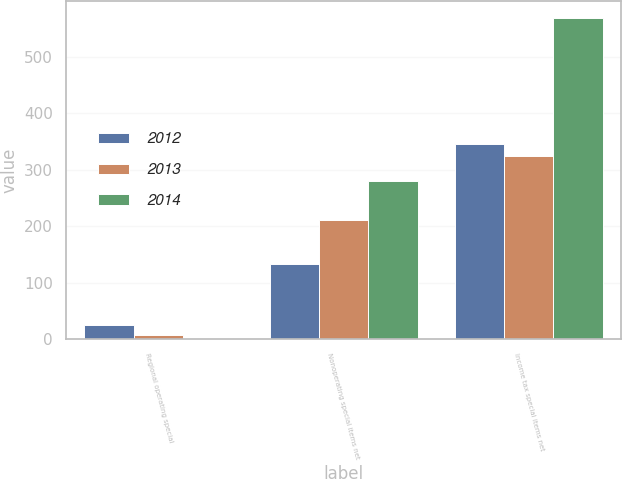<chart> <loc_0><loc_0><loc_500><loc_500><stacked_bar_chart><ecel><fcel>Regional operating special<fcel>Nonoperating special items net<fcel>Income tax special items net<nl><fcel>2012<fcel>24<fcel>132<fcel>346<nl><fcel>2013<fcel>8<fcel>211<fcel>324<nl><fcel>2014<fcel>1<fcel>280<fcel>569<nl></chart> 